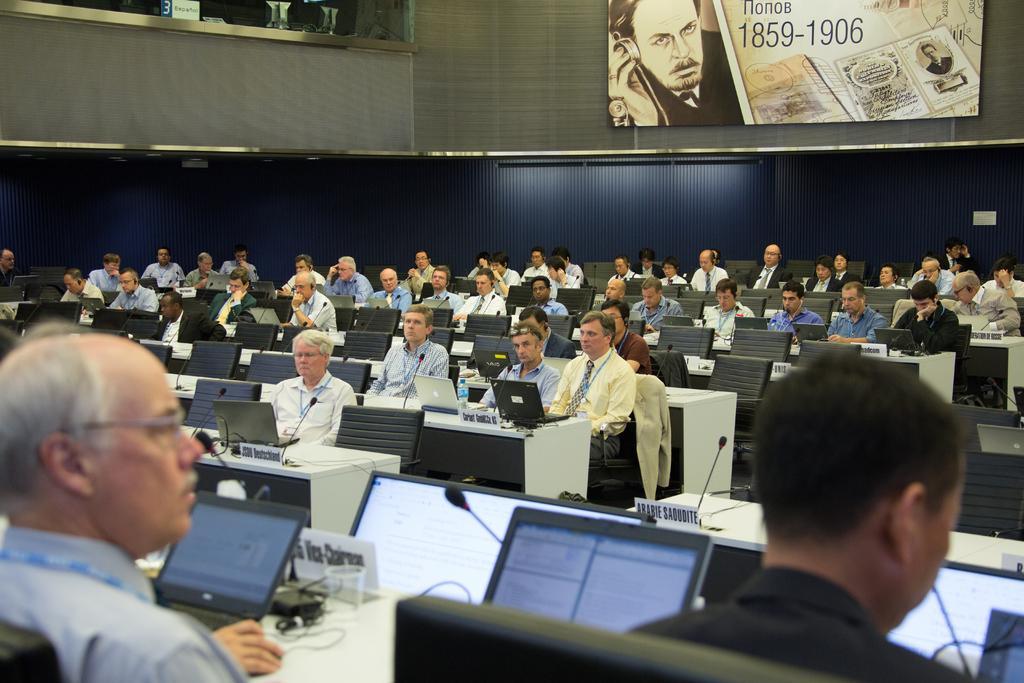Can you describe this image briefly? In this picture there are two persons were sitting on the chair. Beside them we can see the table. On the table we can see laptops, cables and mic. In the background we can see many peoples were sitting on the chair near to the table. At the top we can see the banner near to the wall. 